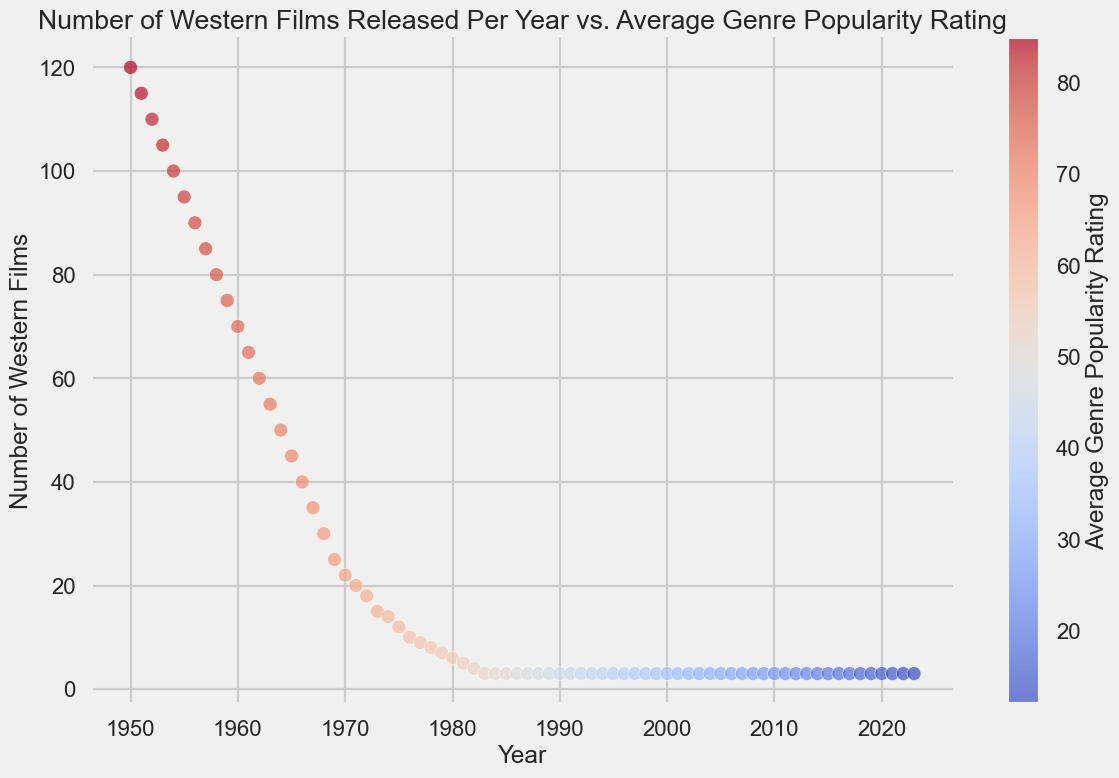What's the trend in the number of Western films released over the years? The scatter plot shows a steady decrease in the number of Western films released each year. In 1950, around 120 Western films were released, but this number continuously drops to about 3 films per year by the early 1980s, remaining consistent thereafter.
Answer: Decreasing How does the average genre popularity rating change over the time period shown? The average genre popularity rating steadily declines over the years, starting from around 85 in 1950 and dropping to about 12 in 2023.
Answer: Decreasing What is the range of the average genre popularity ratings shown in the plot? The highest average genre popularity rating shown is around 85 in 1950, and the lowest is around 12 in 2023.
Answer: 12-85 Which decade experienced the fastest decline in the number of Western films released? The scatter plot shows a sharp decline in the number of Western films released during the 1950s and 1960s. For example, from 1950 to 1960, the number drops from 120 to 70 films.
Answer: 1950s-1960s Is there a year where the number of Western films released and the average genre popularity rating intersect at a significant point? Not specifically; the continuous decrease in both quantity and popularity rating doesn't show a particular intersection point or significant event within a single year according to the visual trend.
Answer: No How does the color of the points change from 1950 to 2023? The color of the points changes from a warmer color (e.g., red/orange) in the earlier years (1950) to a cooler color (e.g., blue) in the later years (2023), reflecting the decreasing average genre popularity rating.
Answer: From warm to cool During which period did the average genre popularity rating fall below 50 for the first time? Looking at the scatter plot, the average genre popularity rating falls below 50 around the mid-1980s.
Answer: Mid-1980s Compare the number of Western films released in 1960 to the number of films released in 1980. In 1960, approximately 70 Western films were released, while in 1980, just about 6 films were released, indicating a significant decline.
Answer: 70 vs. 6 What two features in the scatter plot can be used to determine the trend in the number of Western films over time? The scatter plot uses the y-axis to show the number of Western films and the x-axis to show the year, which together display a clear declining trend.
Answer: Number of films (y-axis) and Year (x-axis) 